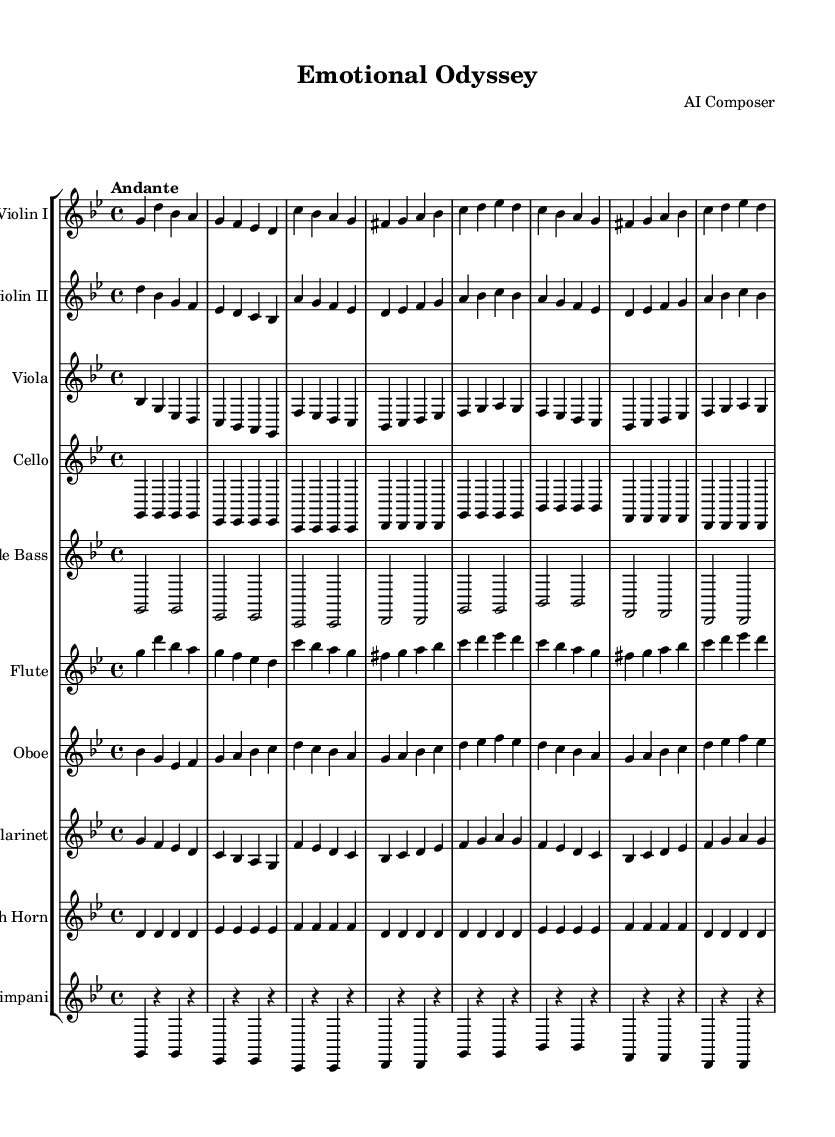What is the key signature of this music? The key signature is indicated at the beginning of the score. There are two flats shown, which means it is in a minor key. The note that is lowered by a flat determines the key as G minor.
Answer: G minor What is the time signature of this music? The time signature appears at the beginning of the score, indicated by the numbers above the staff. There are four beats per measure indicated by "4" on top and "4" at the bottom.
Answer: 4/4 What is the tempo marking for this piece? The tempo marking is specified in the score as "Andante," which suggests a moderate and flowing tempo.
Answer: Andante How many instruments are used in this score? Counting the respective staves listed in the score, there are ten individual instruments indicated: Violin I, Violin II, Viola, Cello, Double Bass, Flute, Oboe, Clarinet, French Horn, and Timpani.
Answer: Ten Which instruments play the main theme? The main theme is represented by the Violin I and Flute parts in the score, where the melodic line is most prominent. This can be identified by their respective notations aligned with the main theme description.
Answer: Violin I and Flute What is the rhythmic pattern of the Timpani? The Timpani part shows a rhythm consisting of quarter notes with rests in between. The notation indicates the pattern of strikes separated by rests emphasizing the beat.
Answer: Quarter notes with rests Which instrument has the highest pitch in this score? The Flute plays the highest pitch as indicated by its part, featured in the treble clef and having notes at a higher octave compared to the other strings and brass instruments.
Answer: Flute 